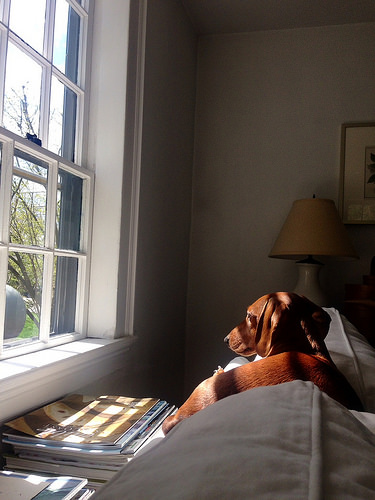<image>
Is the dog behind the couch? No. The dog is not behind the couch. From this viewpoint, the dog appears to be positioned elsewhere in the scene. Is the dog under the window? No. The dog is not positioned under the window. The vertical relationship between these objects is different. Is there a dog in front of the window? Yes. The dog is positioned in front of the window, appearing closer to the camera viewpoint. 